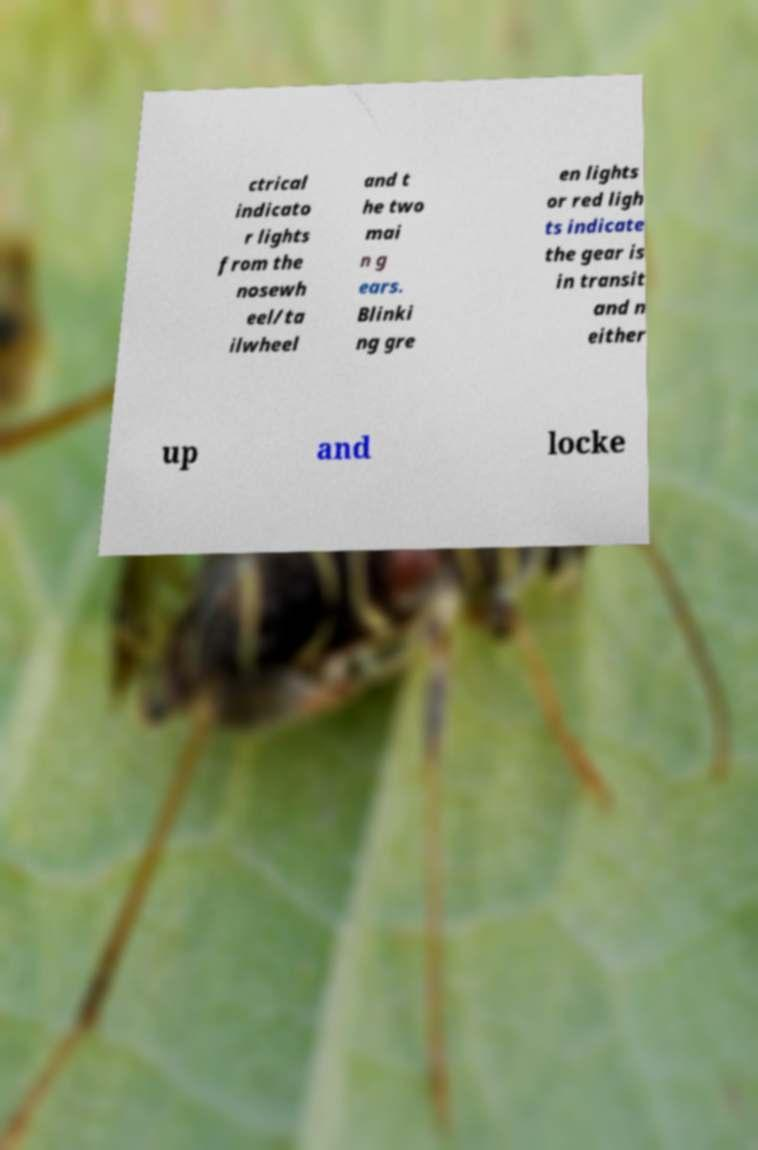Could you extract and type out the text from this image? ctrical indicato r lights from the nosewh eel/ta ilwheel and t he two mai n g ears. Blinki ng gre en lights or red ligh ts indicate the gear is in transit and n either up and locke 